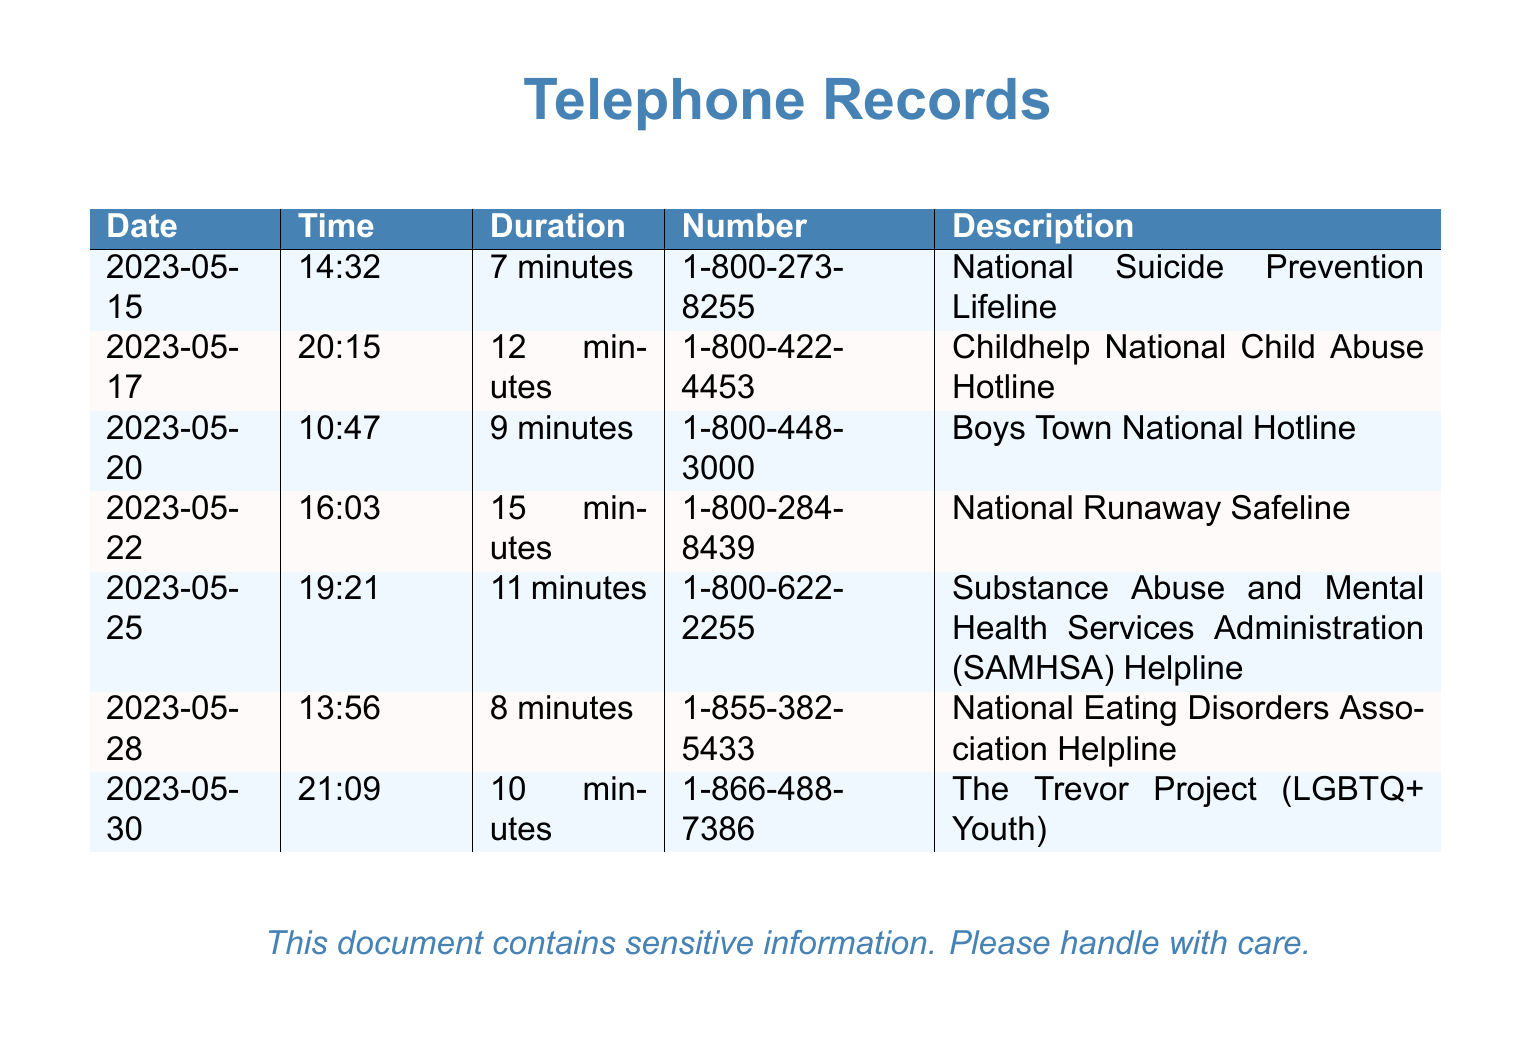what is the duration of the call to the National Suicide Prevention Lifeline? The duration of this call is detailed in the document, showing a 7 minute call on the date provided.
Answer: 7 minutes how many minutes was the call to the National Runaway Safeline? The document lists the National Runaway Safeline call lasting for 15 minutes on the specified date.
Answer: 15 minutes what number was called for the Childhelp National Child Abuse Hotline? The document includes the specific hotline number for this service, which is clearly stated.
Answer: 1-800-422-4453 which hotline was called on May 30, 2023? The document indicates that on this date, a call was made to The Trevor Project as noted in the records.
Answer: The Trevor Project (LGBTQ+ Youth) what is the total number of hotline calls recorded in the document? By counting the number of entries in the table, the total number of hotline calls can be determined from the records presented.
Answer: 7 calls which service is for eating disorders? From the document, one entry clearly indicates the hotline associated with eating disorders, specifying the related service.
Answer: National Eating Disorders Association Helpline what is the shortest duration of the calls recorded? By comparing the duration of each call listed in the document, one can identify the shortest call duration among all entries.
Answer: 7 minutes which hotline is associated with substance abuse? The document specifies that one of the hotlines listed is focused on substance abuse issues, providing its official name.
Answer: Substance Abuse and Mental Health Services Administration (SAMHSA) Helpline 